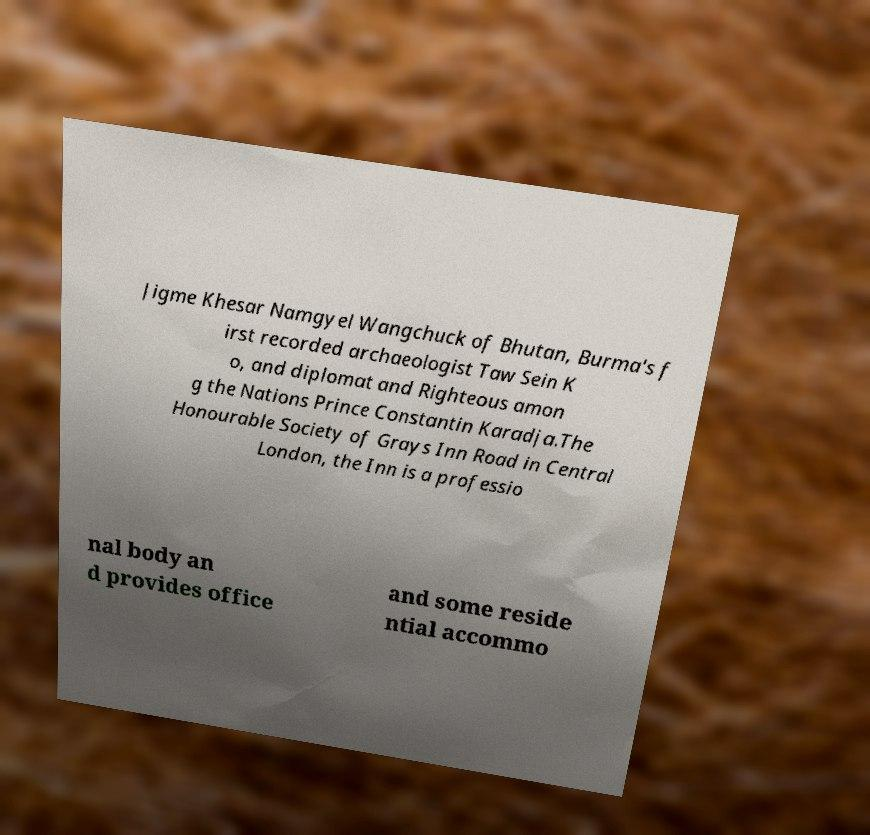There's text embedded in this image that I need extracted. Can you transcribe it verbatim? Jigme Khesar Namgyel Wangchuck of Bhutan, Burma's f irst recorded archaeologist Taw Sein K o, and diplomat and Righteous amon g the Nations Prince Constantin Karadja.The Honourable Society of Grays Inn Road in Central London, the Inn is a professio nal body an d provides office and some reside ntial accommo 